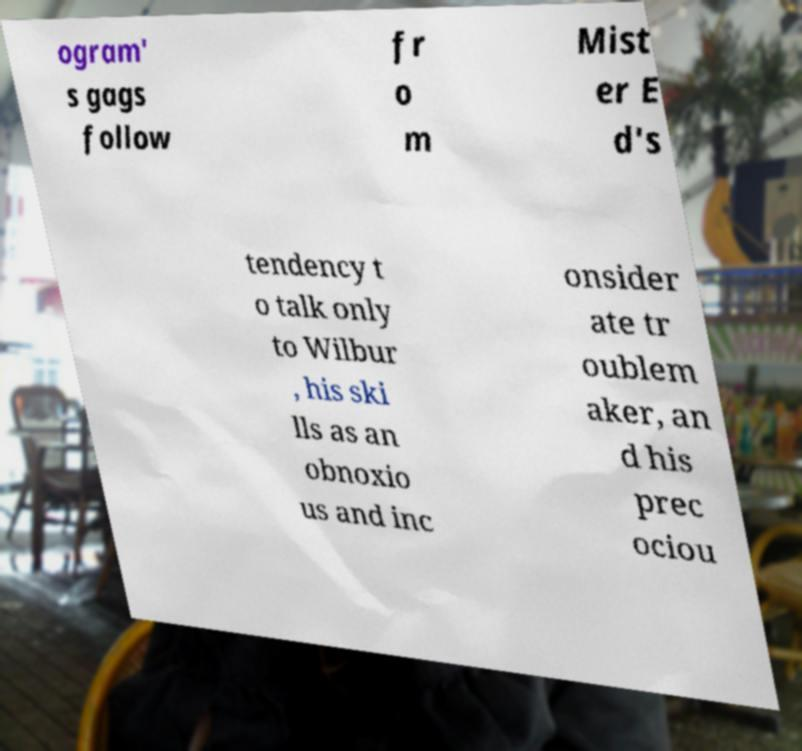Can you accurately transcribe the text from the provided image for me? ogram' s gags follow fr o m Mist er E d's tendency t o talk only to Wilbur , his ski lls as an obnoxio us and inc onsider ate tr oublem aker, an d his prec ociou 